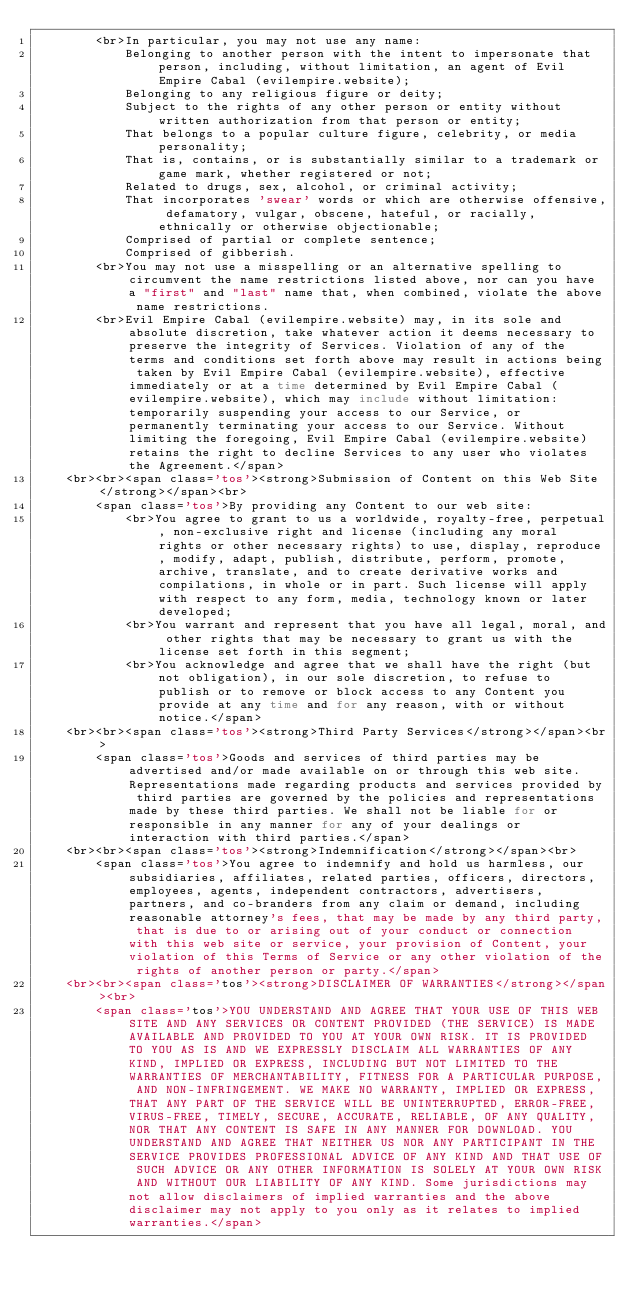Convert code to text. <code><loc_0><loc_0><loc_500><loc_500><_PHP_>        <br>In particular, you may not use any name:
            Belonging to another person with the intent to impersonate that person, including, without limitation, an agent of Evil Empire Cabal (evilempire.website);
            Belonging to any religious figure or deity;
            Subject to the rights of any other person or entity without written authorization from that person or entity;
            That belongs to a popular culture figure, celebrity, or media personality;
            That is, contains, or is substantially similar to a trademark or game mark, whether registered or not;
            Related to drugs, sex, alcohol, or criminal activity;
            That incorporates 'swear' words or which are otherwise offensive, defamatory, vulgar, obscene, hateful, or racially, ethnically or otherwise objectionable;
            Comprised of partial or complete sentence;
            Comprised of gibberish.
        <br>You may not use a misspelling or an alternative spelling to circumvent the name restrictions listed above, nor can you have a "first" and "last" name that, when combined, violate the above name restrictions.
        <br>Evil Empire Cabal (evilempire.website) may, in its sole and absolute discretion, take whatever action it deems necessary to preserve the integrity of Services. Violation of any of the terms and conditions set forth above may result in actions being taken by Evil Empire Cabal (evilempire.website), effective immediately or at a time determined by Evil Empire Cabal (evilempire.website), which may include without limitation: temporarily suspending your access to our Service, or permanently terminating your access to our Service. Without limiting the foregoing, Evil Empire Cabal (evilempire.website) retains the right to decline Services to any user who violates the Agreement.</span>
    <br><br><span class='tos'><strong>Submission of Content on this Web Site</strong></span><br>
        <span class='tos'>By providing any Content to our web site:
            <br>You agree to grant to us a worldwide, royalty-free, perpetual, non-exclusive right and license (including any moral rights or other necessary rights) to use, display, reproduce, modify, adapt, publish, distribute, perform, promote, archive, translate, and to create derivative works and compilations, in whole or in part. Such license will apply with respect to any form, media, technology known or later developed;
            <br>You warrant and represent that you have all legal, moral, and other rights that may be necessary to grant us with the license set forth in this segment;
            <br>You acknowledge and agree that we shall have the right (but not obligation), in our sole discretion, to refuse to publish or to remove or block access to any Content you provide at any time and for any reason, with or without notice.</span>
    <br><br><span class='tos'><strong>Third Party Services</strong></span><br>
        <span class='tos'>Goods and services of third parties may be advertised and/or made available on or through this web site. Representations made regarding products and services provided by third parties are governed by the policies and representations made by these third parties. We shall not be liable for or responsible in any manner for any of your dealings or interaction with third parties.</span>
    <br><br><span class='tos'><strong>Indemnification</strong></span><br>
        <span class='tos'>You agree to indemnify and hold us harmless, our subsidiaries, affiliates, related parties, officers, directors, employees, agents, independent contractors, advertisers, partners, and co-branders from any claim or demand, including reasonable attorney's fees, that may be made by any third party, that is due to or arising out of your conduct or connection with this web site or service, your provision of Content, your violation of this Terms of Service or any other violation of the rights of another person or party.</span>
    <br><br><span class='tos'><strong>DISCLAIMER OF WARRANTIES</strong></span><br>
        <span class='tos'>YOU UNDERSTAND AND AGREE THAT YOUR USE OF THIS WEB SITE AND ANY SERVICES OR CONTENT PROVIDED (THE SERVICE) IS MADE AVAILABLE AND PROVIDED TO YOU AT YOUR OWN RISK. IT IS PROVIDED TO YOU AS IS AND WE EXPRESSLY DISCLAIM ALL WARRANTIES OF ANY KIND, IMPLIED OR EXPRESS, INCLUDING BUT NOT LIMITED TO THE WARRANTIES OF MERCHANTABILITY, FITNESS FOR A PARTICULAR PURPOSE, AND NON-INFRINGEMENT. WE MAKE NO WARRANTY, IMPLIED OR EXPRESS, THAT ANY PART OF THE SERVICE WILL BE UNINTERRUPTED, ERROR-FREE, VIRUS-FREE, TIMELY, SECURE, ACCURATE, RELIABLE, OF ANY QUALITY, NOR THAT ANY CONTENT IS SAFE IN ANY MANNER FOR DOWNLOAD. YOU UNDERSTAND AND AGREE THAT NEITHER US NOR ANY PARTICIPANT IN THE SERVICE PROVIDES PROFESSIONAL ADVICE OF ANY KIND AND THAT USE OF SUCH ADVICE OR ANY OTHER INFORMATION IS SOLELY AT YOUR OWN RISK AND WITHOUT OUR LIABILITY OF ANY KIND. Some jurisdictions may not allow disclaimers of implied warranties and the above disclaimer may not apply to you only as it relates to implied warranties.</span></code> 